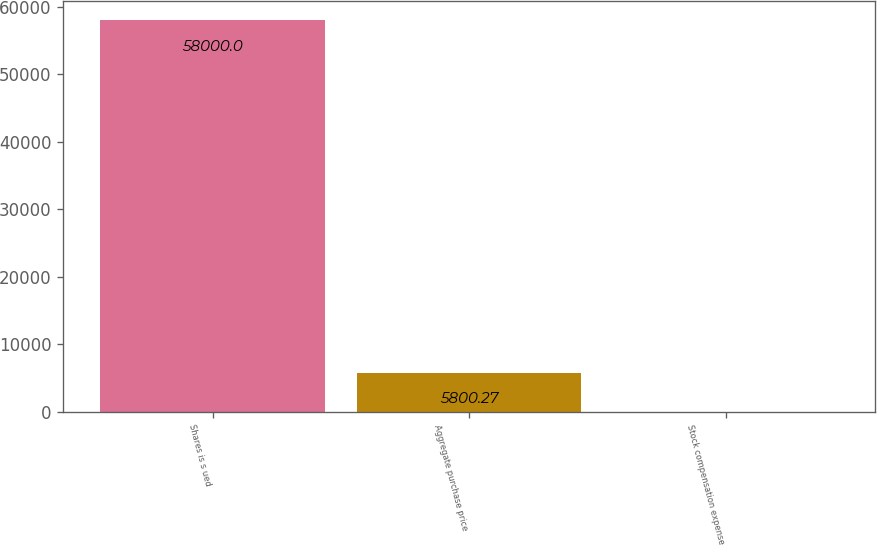<chart> <loc_0><loc_0><loc_500><loc_500><bar_chart><fcel>Shares is s ued<fcel>Aggregate purchase price<fcel>Stock compensation expense<nl><fcel>58000<fcel>5800.27<fcel>0.3<nl></chart> 